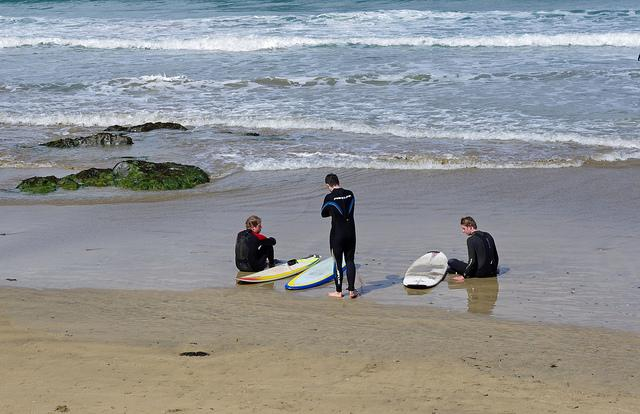What is the green substance near the shoreline? algae 